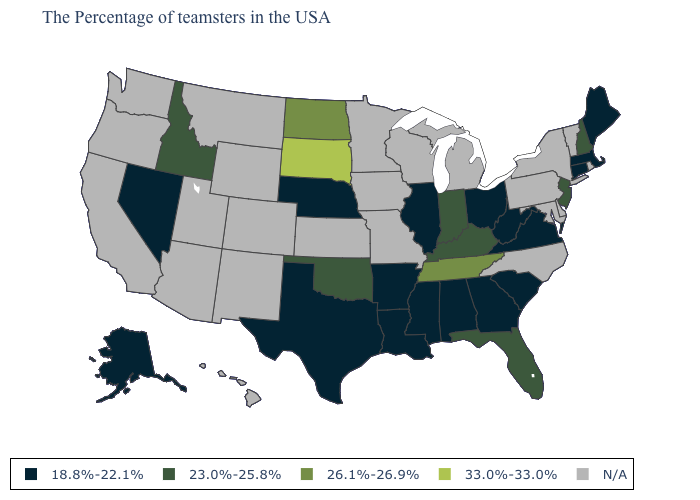What is the highest value in the USA?
Write a very short answer. 33.0%-33.0%. Among the states that border Utah , which have the lowest value?
Write a very short answer. Nevada. Which states hav the highest value in the West?
Write a very short answer. Idaho. Does the map have missing data?
Keep it brief. Yes. What is the value of North Carolina?
Be succinct. N/A. What is the highest value in the South ?
Concise answer only. 26.1%-26.9%. What is the value of Pennsylvania?
Short answer required. N/A. Name the states that have a value in the range 18.8%-22.1%?
Be succinct. Maine, Massachusetts, Connecticut, Virginia, South Carolina, West Virginia, Ohio, Georgia, Alabama, Illinois, Mississippi, Louisiana, Arkansas, Nebraska, Texas, Nevada, Alaska. Does Illinois have the lowest value in the MidWest?
Write a very short answer. Yes. What is the value of Arkansas?
Write a very short answer. 18.8%-22.1%. Name the states that have a value in the range N/A?
Write a very short answer. Rhode Island, Vermont, New York, Delaware, Maryland, Pennsylvania, North Carolina, Michigan, Wisconsin, Missouri, Minnesota, Iowa, Kansas, Wyoming, Colorado, New Mexico, Utah, Montana, Arizona, California, Washington, Oregon, Hawaii. What is the highest value in the West ?
Quick response, please. 23.0%-25.8%. Name the states that have a value in the range 26.1%-26.9%?
Answer briefly. Tennessee, North Dakota. Name the states that have a value in the range 26.1%-26.9%?
Keep it brief. Tennessee, North Dakota. Name the states that have a value in the range 18.8%-22.1%?
Concise answer only. Maine, Massachusetts, Connecticut, Virginia, South Carolina, West Virginia, Ohio, Georgia, Alabama, Illinois, Mississippi, Louisiana, Arkansas, Nebraska, Texas, Nevada, Alaska. 